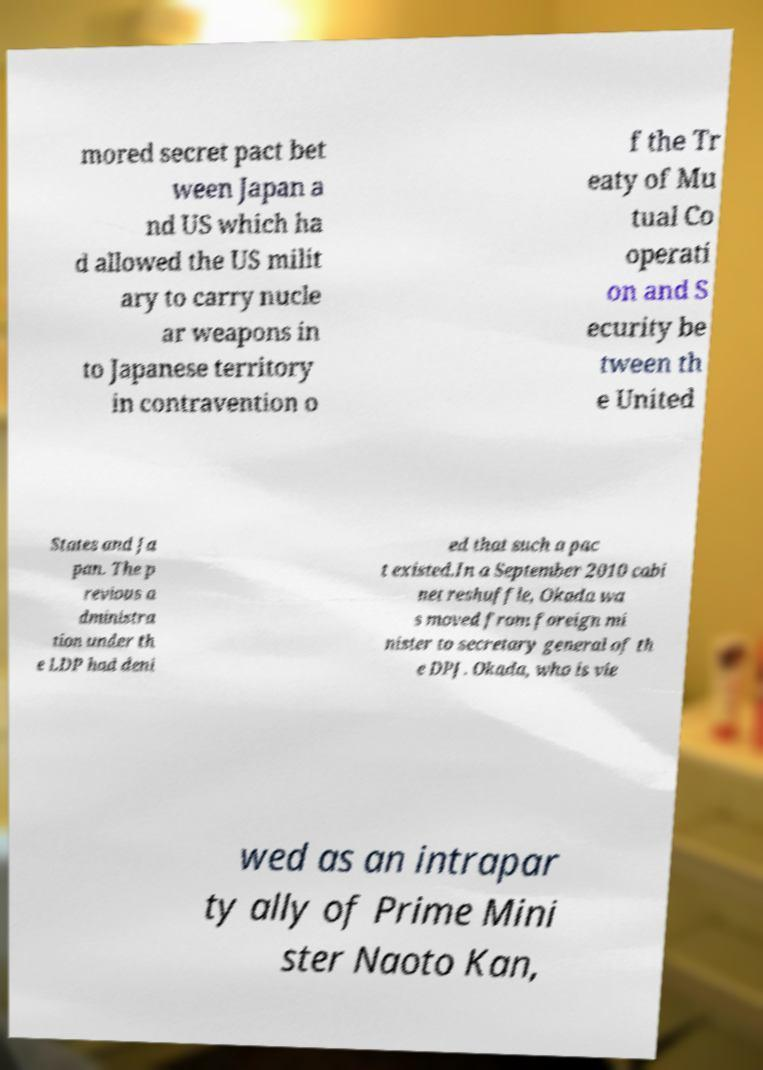Could you assist in decoding the text presented in this image and type it out clearly? mored secret pact bet ween Japan a nd US which ha d allowed the US milit ary to carry nucle ar weapons in to Japanese territory in contravention o f the Tr eaty of Mu tual Co operati on and S ecurity be tween th e United States and Ja pan. The p revious a dministra tion under th e LDP had deni ed that such a pac t existed.In a September 2010 cabi net reshuffle, Okada wa s moved from foreign mi nister to secretary general of th e DPJ. Okada, who is vie wed as an intrapar ty ally of Prime Mini ster Naoto Kan, 